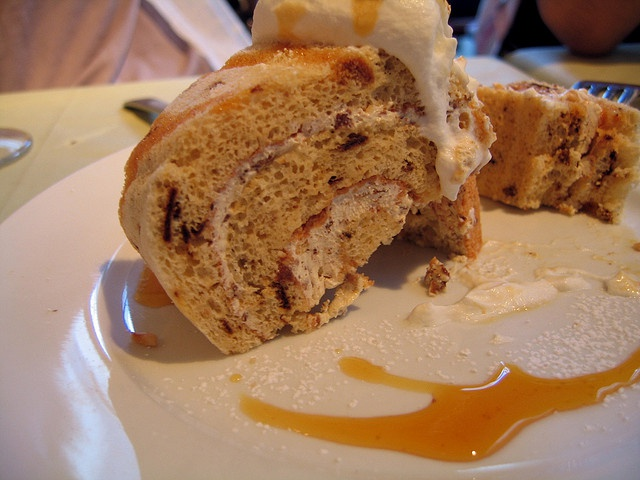Describe the objects in this image and their specific colors. I can see cake in maroon, brown, gray, and tan tones, cake in maroon, brown, and tan tones, spoon in maroon, gray, tan, and darkgray tones, and spoon in maroon, gray, olive, and darkgray tones in this image. 